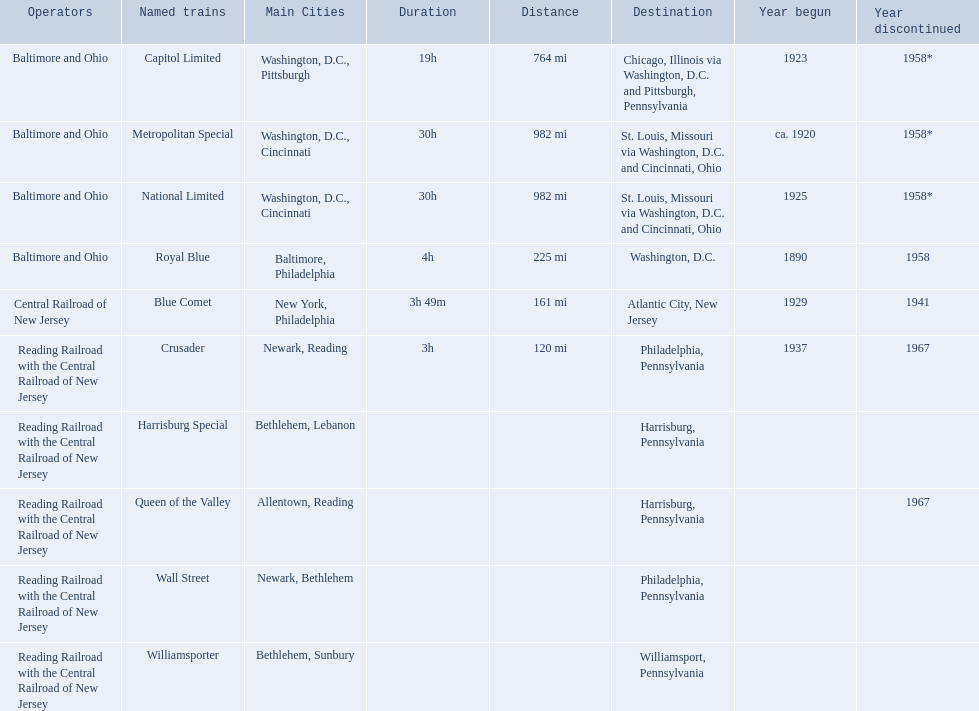What are the destinations of the central railroad of new jersey terminal? Chicago, Illinois via Washington, D.C. and Pittsburgh, Pennsylvania, St. Louis, Missouri via Washington, D.C. and Cincinnati, Ohio, St. Louis, Missouri via Washington, D.C. and Cincinnati, Ohio, Washington, D.C., Atlantic City, New Jersey, Philadelphia, Pennsylvania, Harrisburg, Pennsylvania, Harrisburg, Pennsylvania, Philadelphia, Pennsylvania, Williamsport, Pennsylvania. Which of these destinations is at the top of the list? Chicago, Illinois via Washington, D.C. and Pittsburgh, Pennsylvania. Which operators are the reading railroad with the central railroad of new jersey? Reading Railroad with the Central Railroad of New Jersey, Reading Railroad with the Central Railroad of New Jersey, Reading Railroad with the Central Railroad of New Jersey, Reading Railroad with the Central Railroad of New Jersey, Reading Railroad with the Central Railroad of New Jersey. Which destinations are philadelphia, pennsylvania? Philadelphia, Pennsylvania, Philadelphia, Pennsylvania. What on began in 1937? 1937. What is the named train? Crusader. 